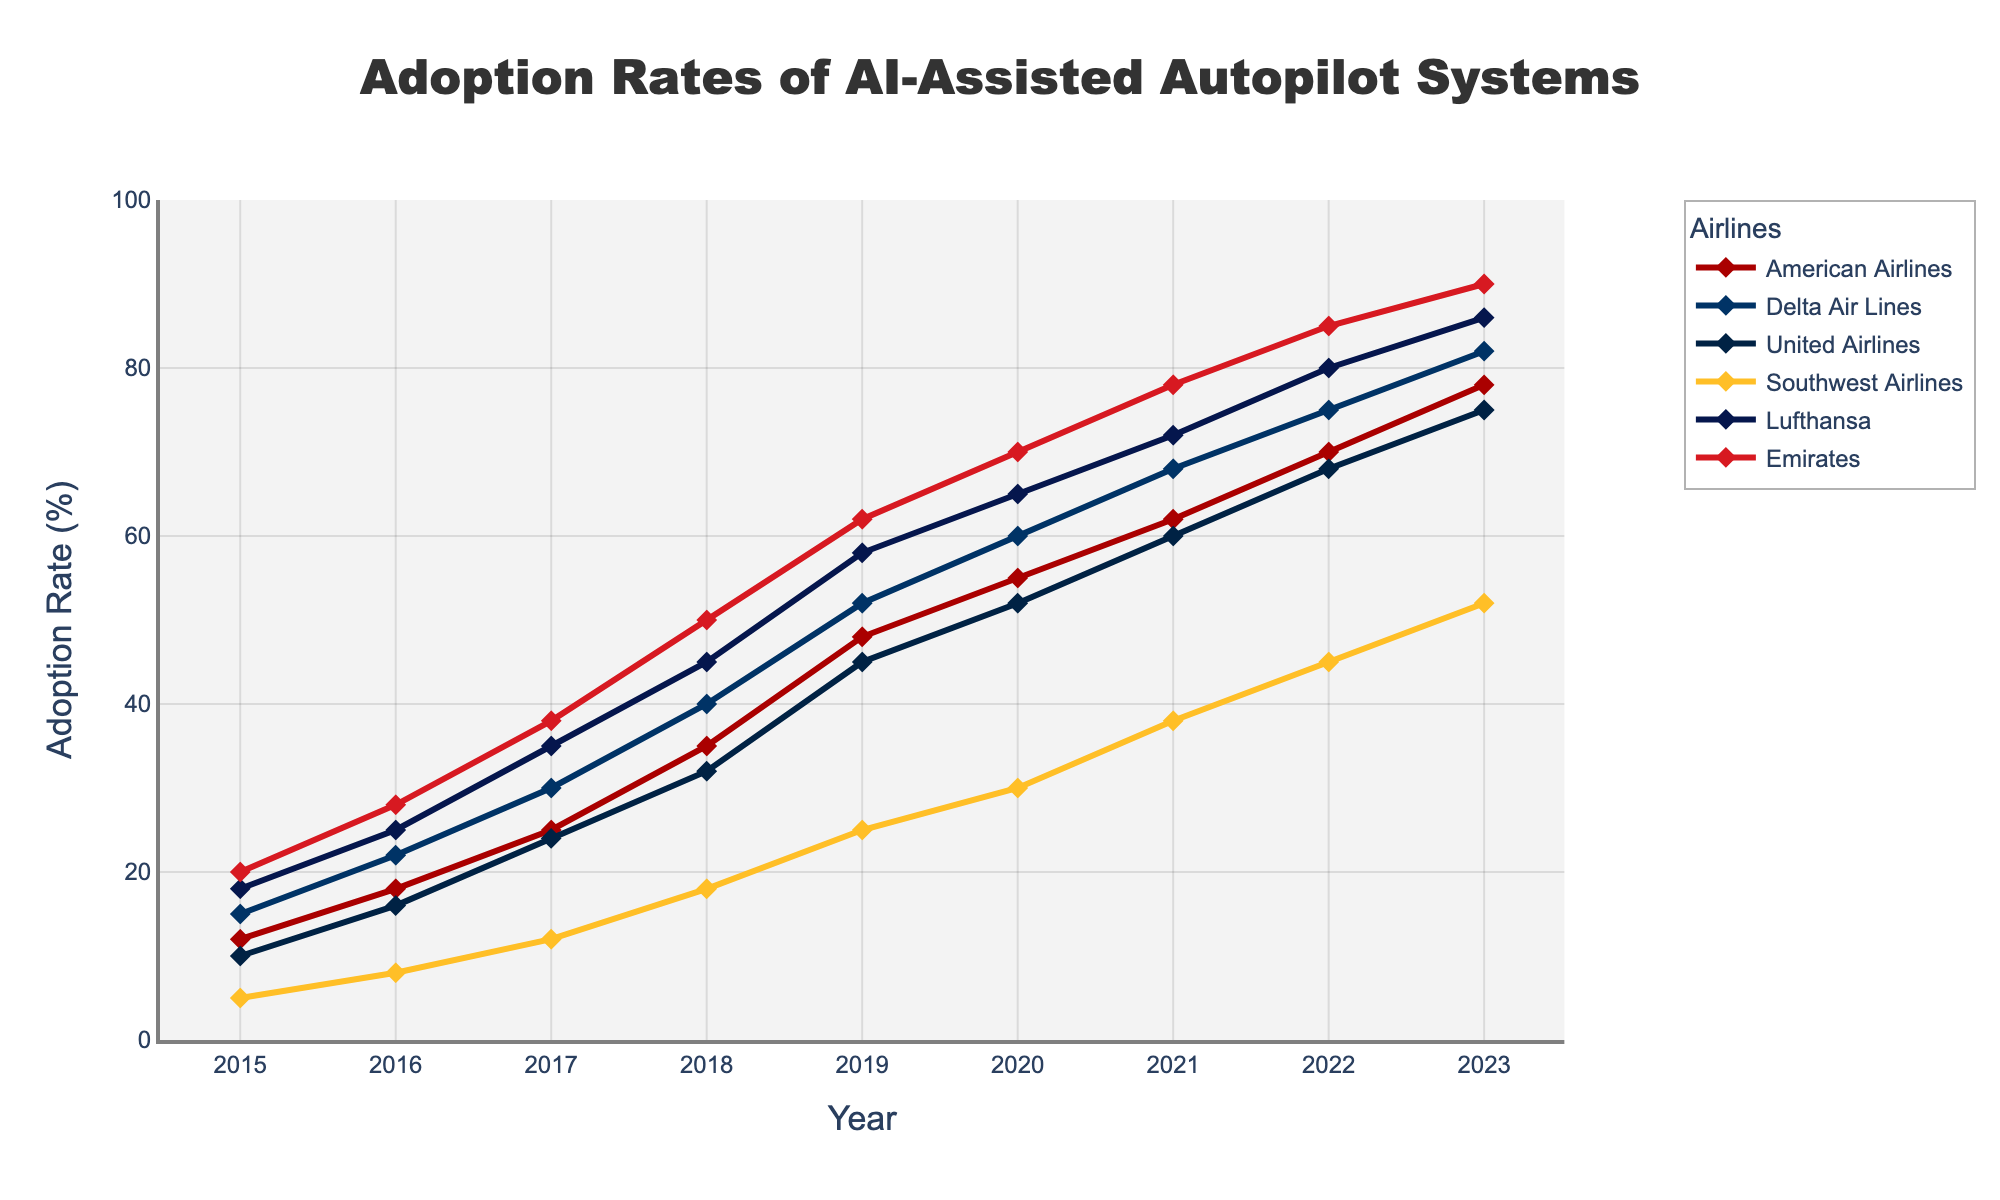Which airline had the highest adoption rate of AI-assisted autopilot systems in 2023? Look for the airline with the highest value in 2023. Emirates shows the highest adoption rate.
Answer: Emirates Which airline experienced the greatest increase in adoption rate between 2017 and 2020? Calculate the differences for each airline between 2017 and 2020 and compare. Emirates: 70 - 38 = 32, Lufthansa: 65 - 35 = 30, others are lower.
Answer: Emirates How many times did American Airlines' adoption rate increase by 10% or more year-over-year? Check for each year if the adoption rate increased by 10% or more compared to the previous year. Increases of 10% or more occurred 4 times for American Airlines: (2016-2015), (2018-2017), (2019-2018), (2020-2019).
Answer: 4 Which airline had the slowest adoption rate growth from 2015 to 2023? Compare the overall increase from 2015 to 2023 for each airline. Southwest Airlines: 52 - 5 = 47, others have higher increases.
Answer: Southwest Airlines Did Southwest Airlines ever surpass an adoption rate of 50% between 2015 and 2023? Check the values for Southwest Airlines across the years. Southwest Airlines reached exactly 52% in 2023.
Answer: Yes In which year did Lufthansa surpass 50% adoption rate for the first time? Look for the first year where Lufthansa's adoption rate crosses 50%. The year is 2018.
Answer: 2018 Compare the adoption rates of Delta Air Lines and United Airlines in 2020. Which one is higher and by how much? Look at the values in 2020 for Delta Air Lines (60%) and United Airlines (52%). Delta Air Lines’ rate is higher by 60% - 52% = 8%.
Answer: Delta Air Lines by 8% What is the average adoption rate of AI-assisted autopilot systems for Emirates across all years? Sum up all Emirates values and divide by the number of years (9). (20 + 28 + 38 + 50 + 62 + 70 + 78 + 85 + 90) / 9 = 57
Answer: 57 How much did the adoption rate of American Airlines change from 2015 to 2023? Subtract the 2015 value from the 2023 value for American Airlines. 78 - 12 = 66
Answer: 66 Which year witnessed the highest overall adoption rate increase across all airlines? Calculate the total adoption across all airlines for each year and find the year with the largest increase compared to the previous year. From 2017 to 2018, the total increase is 50%, which is the highest (American: 10, Delta: 10, United: 8, Southwest: 6, Lufthansa: 10, Emirates: 12).
Answer: 2018 